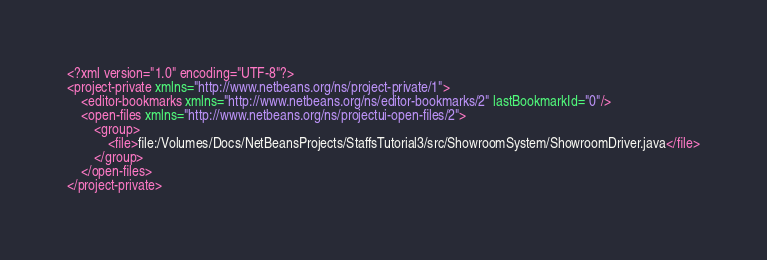<code> <loc_0><loc_0><loc_500><loc_500><_XML_><?xml version="1.0" encoding="UTF-8"?>
<project-private xmlns="http://www.netbeans.org/ns/project-private/1">
    <editor-bookmarks xmlns="http://www.netbeans.org/ns/editor-bookmarks/2" lastBookmarkId="0"/>
    <open-files xmlns="http://www.netbeans.org/ns/projectui-open-files/2">
        <group>
            <file>file:/Volumes/Docs/NetBeansProjects/StaffsTutorial3/src/ShowroomSystem/ShowroomDriver.java</file>
        </group>
    </open-files>
</project-private>
</code> 